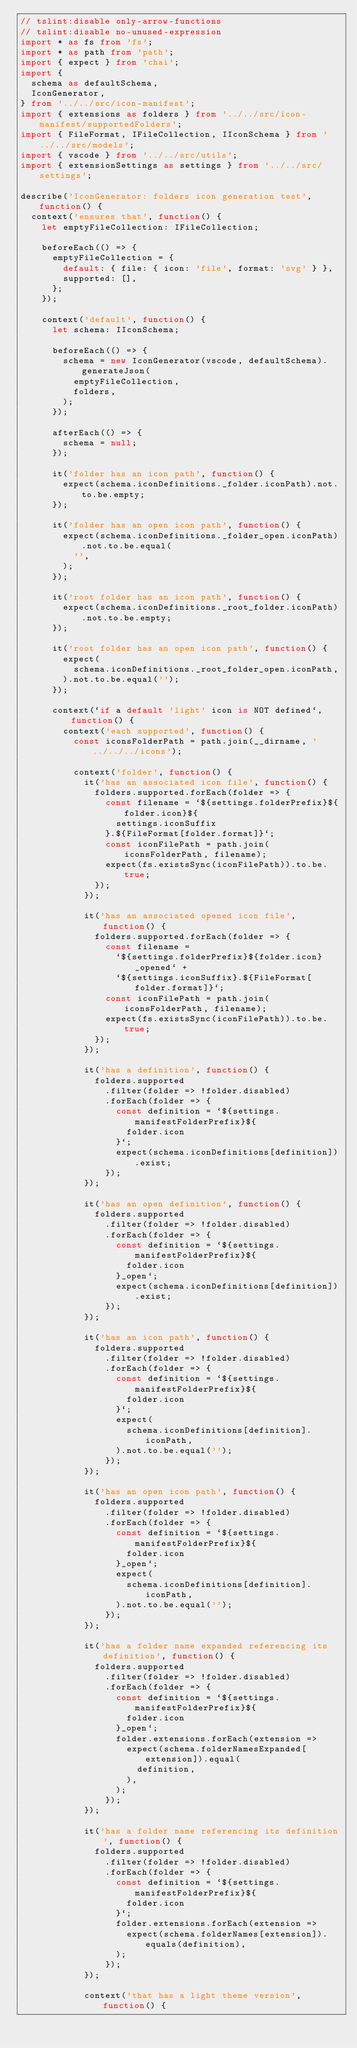Convert code to text. <code><loc_0><loc_0><loc_500><loc_500><_TypeScript_>// tslint:disable only-arrow-functions
// tslint:disable no-unused-expression
import * as fs from 'fs';
import * as path from 'path';
import { expect } from 'chai';
import {
  schema as defaultSchema,
  IconGenerator,
} from '../../src/icon-manifest';
import { extensions as folders } from '../../src/icon-manifest/supportedFolders';
import { FileFormat, IFileCollection, IIconSchema } from '../../src/models';
import { vscode } from '../../src/utils';
import { extensionSettings as settings } from '../../src/settings';

describe('IconGenerator: folders icon generation test', function() {
  context('ensures that', function() {
    let emptyFileCollection: IFileCollection;

    beforeEach(() => {
      emptyFileCollection = {
        default: { file: { icon: 'file', format: 'svg' } },
        supported: [],
      };
    });

    context('default', function() {
      let schema: IIconSchema;

      beforeEach(() => {
        schema = new IconGenerator(vscode, defaultSchema).generateJson(
          emptyFileCollection,
          folders,
        );
      });

      afterEach(() => {
        schema = null;
      });

      it('folder has an icon path', function() {
        expect(schema.iconDefinitions._folder.iconPath).not.to.be.empty;
      });

      it('folder has an open icon path', function() {
        expect(schema.iconDefinitions._folder_open.iconPath).not.to.be.equal(
          '',
        );
      });

      it('root folder has an icon path', function() {
        expect(schema.iconDefinitions._root_folder.iconPath).not.to.be.empty;
      });

      it('root folder has an open icon path', function() {
        expect(
          schema.iconDefinitions._root_folder_open.iconPath,
        ).not.to.be.equal('');
      });

      context(`if a default 'light' icon is NOT defined`, function() {
        context('each supported', function() {
          const iconsFolderPath = path.join(__dirname, '../../../icons');

          context('folder', function() {
            it('has an associated icon file', function() {
              folders.supported.forEach(folder => {
                const filename = `${settings.folderPrefix}${folder.icon}${
                  settings.iconSuffix
                }.${FileFormat[folder.format]}`;
                const iconFilePath = path.join(iconsFolderPath, filename);
                expect(fs.existsSync(iconFilePath)).to.be.true;
              });
            });

            it('has an associated opened icon file', function() {
              folders.supported.forEach(folder => {
                const filename =
                  `${settings.folderPrefix}${folder.icon}_opened` +
                  `${settings.iconSuffix}.${FileFormat[folder.format]}`;
                const iconFilePath = path.join(iconsFolderPath, filename);
                expect(fs.existsSync(iconFilePath)).to.be.true;
              });
            });

            it('has a definition', function() {
              folders.supported
                .filter(folder => !folder.disabled)
                .forEach(folder => {
                  const definition = `${settings.manifestFolderPrefix}${
                    folder.icon
                  }`;
                  expect(schema.iconDefinitions[definition]).exist;
                });
            });

            it('has an open definition', function() {
              folders.supported
                .filter(folder => !folder.disabled)
                .forEach(folder => {
                  const definition = `${settings.manifestFolderPrefix}${
                    folder.icon
                  }_open`;
                  expect(schema.iconDefinitions[definition]).exist;
                });
            });

            it('has an icon path', function() {
              folders.supported
                .filter(folder => !folder.disabled)
                .forEach(folder => {
                  const definition = `${settings.manifestFolderPrefix}${
                    folder.icon
                  }`;
                  expect(
                    schema.iconDefinitions[definition].iconPath,
                  ).not.to.be.equal('');
                });
            });

            it('has an open icon path', function() {
              folders.supported
                .filter(folder => !folder.disabled)
                .forEach(folder => {
                  const definition = `${settings.manifestFolderPrefix}${
                    folder.icon
                  }_open`;
                  expect(
                    schema.iconDefinitions[definition].iconPath,
                  ).not.to.be.equal('');
                });
            });

            it('has a folder name expanded referencing its definition', function() {
              folders.supported
                .filter(folder => !folder.disabled)
                .forEach(folder => {
                  const definition = `${settings.manifestFolderPrefix}${
                    folder.icon
                  }_open`;
                  folder.extensions.forEach(extension =>
                    expect(schema.folderNamesExpanded[extension]).equal(
                      definition,
                    ),
                  );
                });
            });

            it('has a folder name referencing its definition', function() {
              folders.supported
                .filter(folder => !folder.disabled)
                .forEach(folder => {
                  const definition = `${settings.manifestFolderPrefix}${
                    folder.icon
                  }`;
                  folder.extensions.forEach(extension =>
                    expect(schema.folderNames[extension]).equals(definition),
                  );
                });
            });

            context('that has a light theme version', function() {</code> 